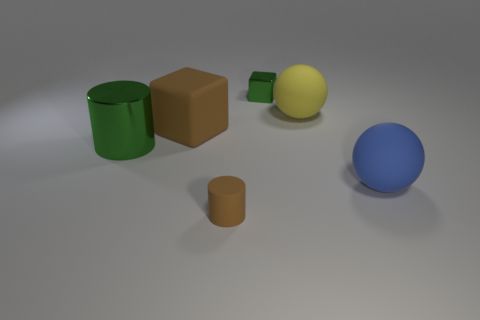Add 3 small purple matte blocks. How many objects exist? 9 Subtract 2 cubes. How many cubes are left? 0 Subtract all brown cylinders. How many cylinders are left? 1 Subtract all cyan blocks. How many brown cylinders are left? 1 Subtract all small brown shiny cylinders. Subtract all yellow things. How many objects are left? 5 Add 4 yellow things. How many yellow things are left? 5 Add 6 large blue things. How many large blue things exist? 7 Subtract 0 red balls. How many objects are left? 6 Subtract all blocks. How many objects are left? 4 Subtract all brown cubes. Subtract all cyan spheres. How many cubes are left? 1 